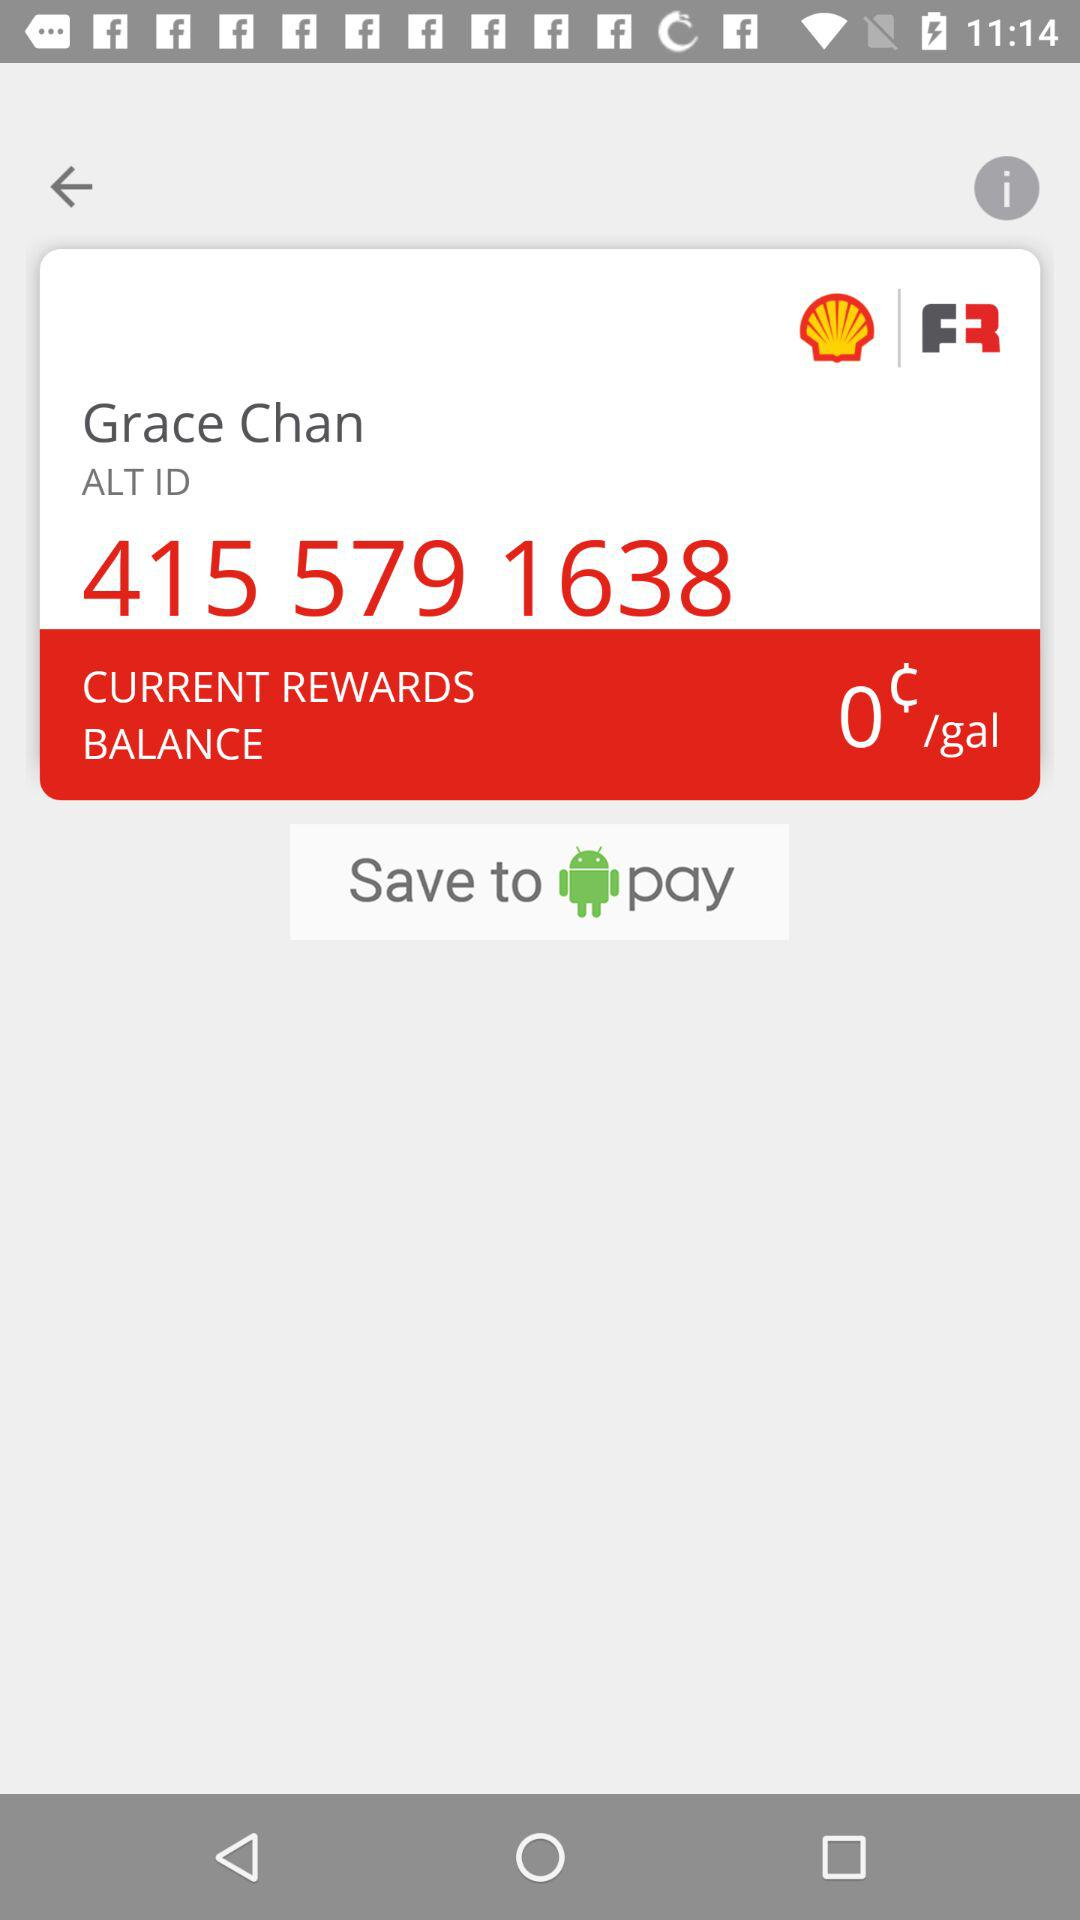What is the ALT ID? The ALT ID is 415 579 1638. 